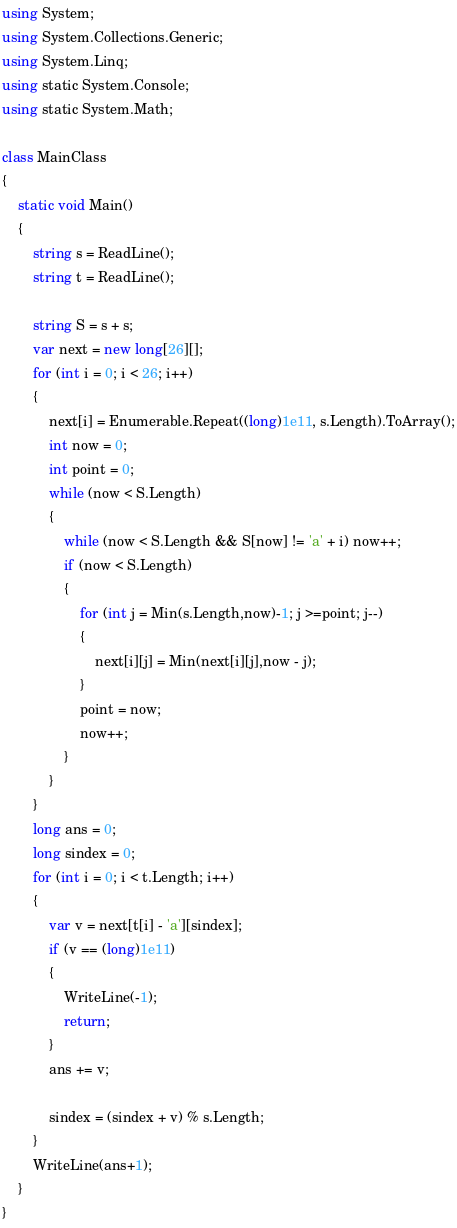<code> <loc_0><loc_0><loc_500><loc_500><_C#_>using System;
using System.Collections.Generic;
using System.Linq;
using static System.Console;
using static System.Math;

class MainClass
{
    static void Main()
    {
        string s = ReadLine();
        string t = ReadLine();

        string S = s + s;
        var next = new long[26][];
        for (int i = 0; i < 26; i++)
        {
            next[i] = Enumerable.Repeat((long)1e11, s.Length).ToArray();
            int now = 0;
            int point = 0;
            while (now < S.Length)
            {
                while (now < S.Length && S[now] != 'a' + i) now++;
                if (now < S.Length)
                {
                    for (int j = Min(s.Length,now)-1; j >=point; j--)
                    {
                        next[i][j] = Min(next[i][j],now - j);
                    }
                    point = now;
                    now++;
                }
            }
        }
        long ans = 0;
        long sindex = 0;
        for (int i = 0; i < t.Length; i++)
        {
            var v = next[t[i] - 'a'][sindex];
            if (v == (long)1e11)
            {
                WriteLine(-1);
                return;
            }
            ans += v;

            sindex = (sindex + v) % s.Length;
        }
        WriteLine(ans+1);
    }
}
</code> 